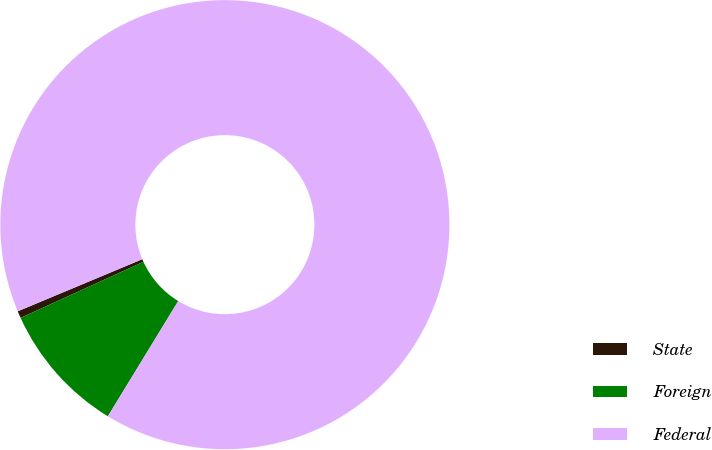Convert chart to OTSL. <chart><loc_0><loc_0><loc_500><loc_500><pie_chart><fcel>State<fcel>Foreign<fcel>Federal<nl><fcel>0.51%<fcel>9.46%<fcel>90.03%<nl></chart> 